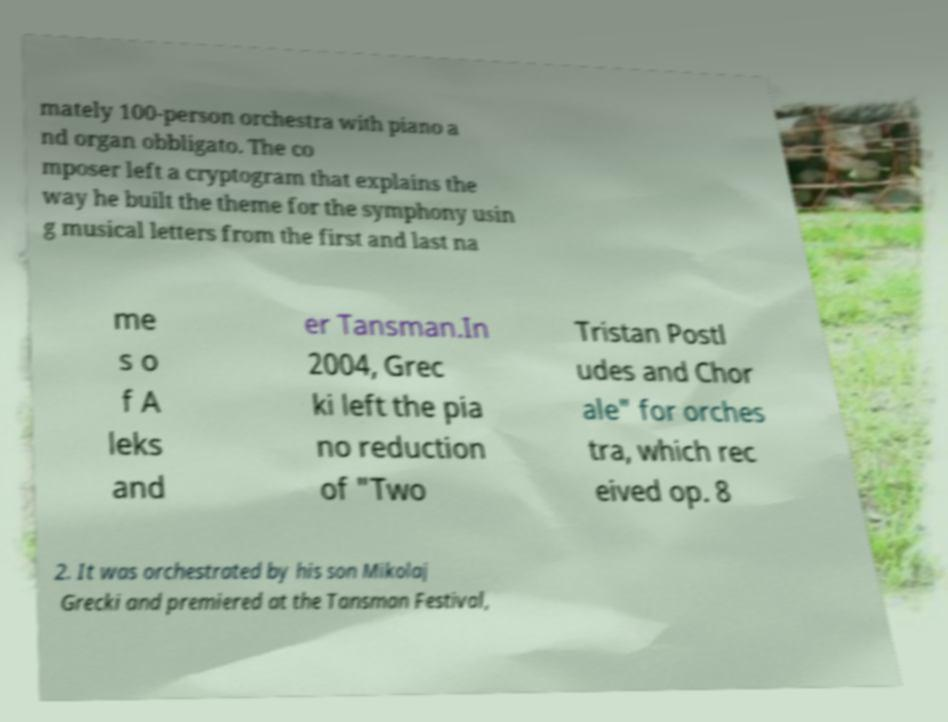Please read and relay the text visible in this image. What does it say? mately 100-person orchestra with piano a nd organ obbligato. The co mposer left a cryptogram that explains the way he built the theme for the symphony usin g musical letters from the first and last na me s o f A leks and er Tansman.In 2004, Grec ki left the pia no reduction of "Two Tristan Postl udes and Chor ale" for orches tra, which rec eived op. 8 2. It was orchestrated by his son Mikolaj Grecki and premiered at the Tansman Festival, 